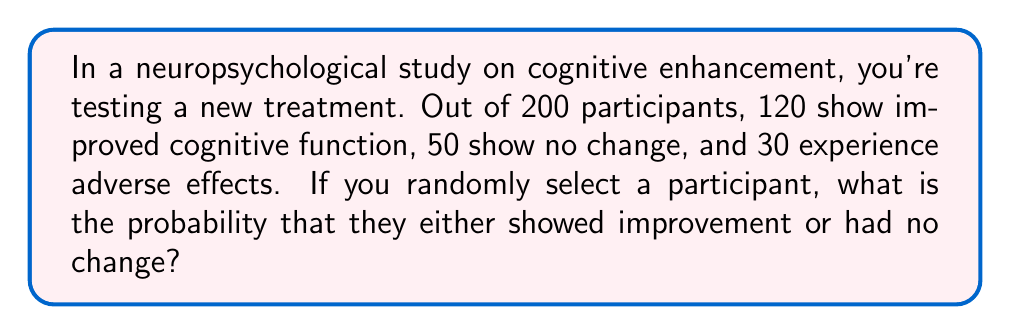Can you answer this question? Let's approach this step-by-step:

1) First, we need to identify the favorable outcomes. In this case, we want participants who either showed improvement or had no change.

   Improved: 120
   No change: 50

2) We can calculate the total number of favorable outcomes by adding these together:

   $120 + 50 = 170$

3) The total number of participants in the study is 200.

4) The probability of an event is calculated by dividing the number of favorable outcomes by the total number of possible outcomes:

   $$P(\text{improvement or no change}) = \frac{\text{favorable outcomes}}{\text{total outcomes}}$$

5) Substituting our values:

   $$P(\text{improvement or no change}) = \frac{170}{200}$$

6) This fraction can be reduced:

   $$\frac{170}{200} = \frac{17}{20} = 0.85$$

Therefore, the probability of randomly selecting a participant who either showed improvement or had no change is 0.85 or 85%.
Answer: $\frac{17}{20}$ or 0.85 